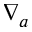Convert formula to latex. <formula><loc_0><loc_0><loc_500><loc_500>\nabla _ { a }</formula> 